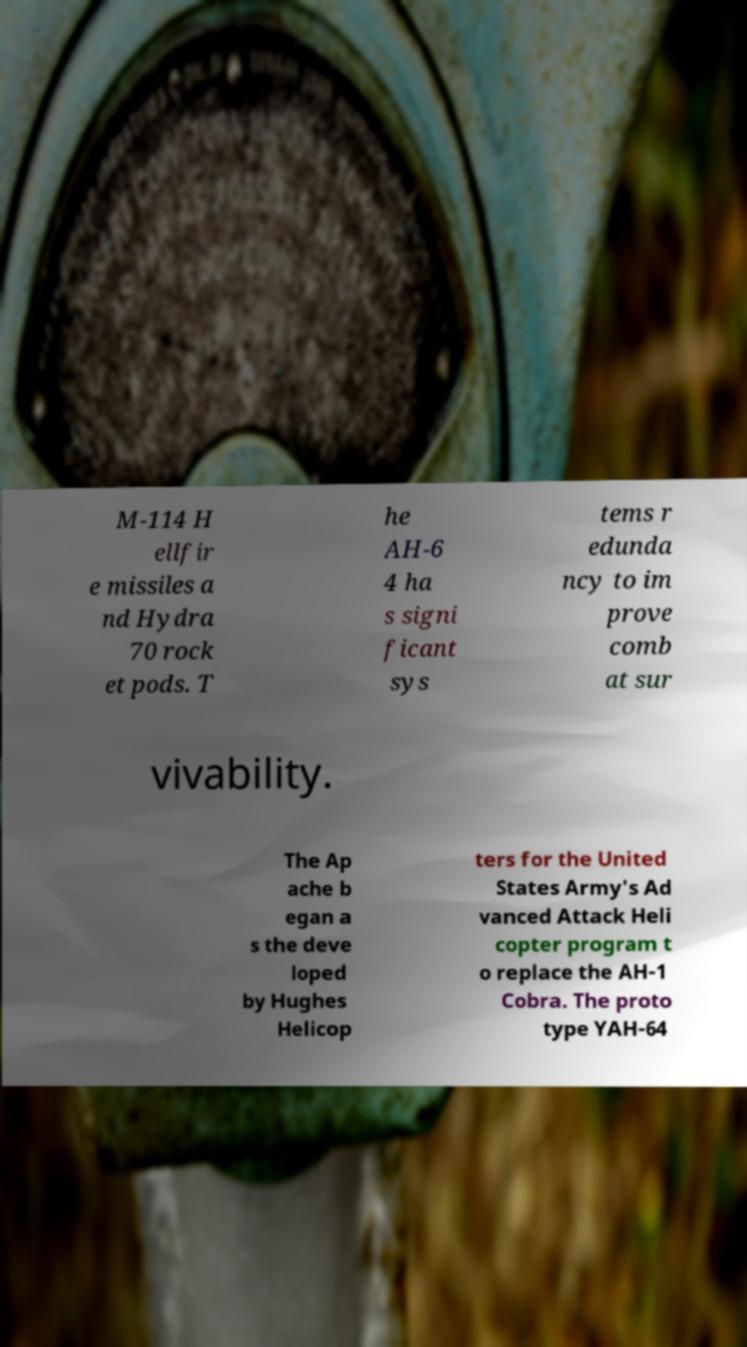Can you accurately transcribe the text from the provided image for me? M-114 H ellfir e missiles a nd Hydra 70 rock et pods. T he AH-6 4 ha s signi ficant sys tems r edunda ncy to im prove comb at sur vivability. The Ap ache b egan a s the deve loped by Hughes Helicop ters for the United States Army's Ad vanced Attack Heli copter program t o replace the AH-1 Cobra. The proto type YAH-64 